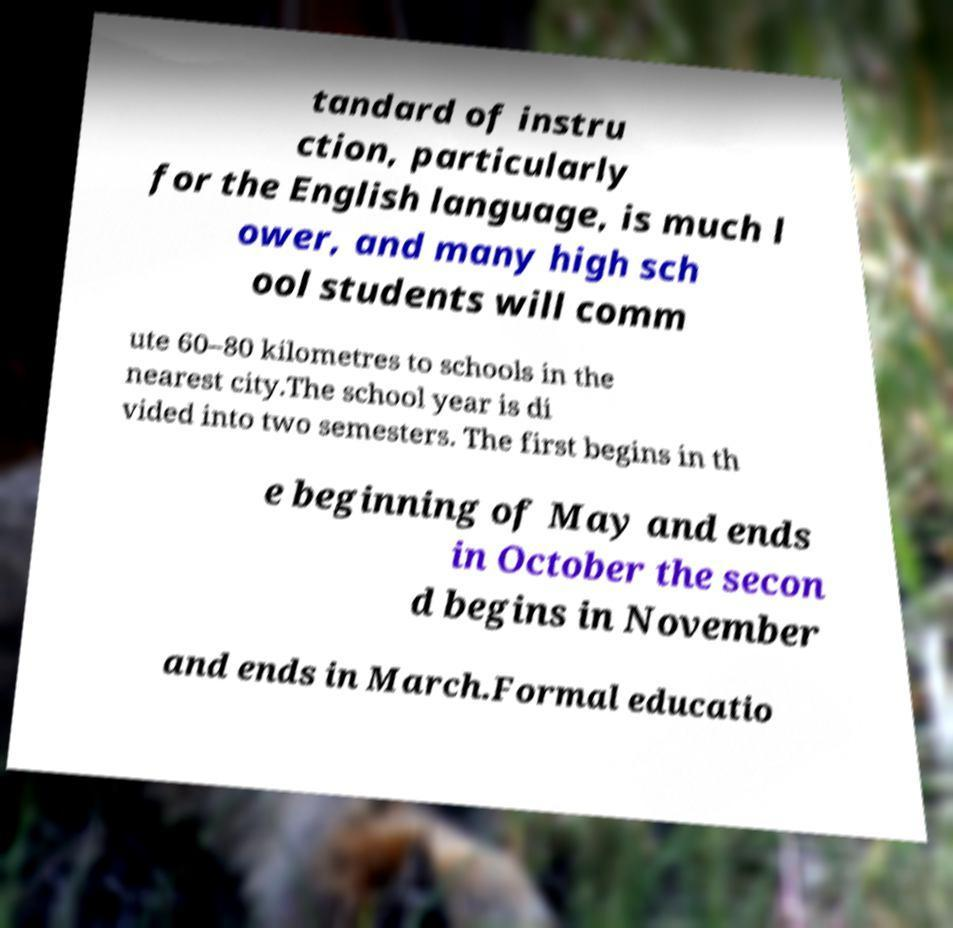I need the written content from this picture converted into text. Can you do that? tandard of instru ction, particularly for the English language, is much l ower, and many high sch ool students will comm ute 60–80 kilometres to schools in the nearest city.The school year is di vided into two semesters. The first begins in th e beginning of May and ends in October the secon d begins in November and ends in March.Formal educatio 